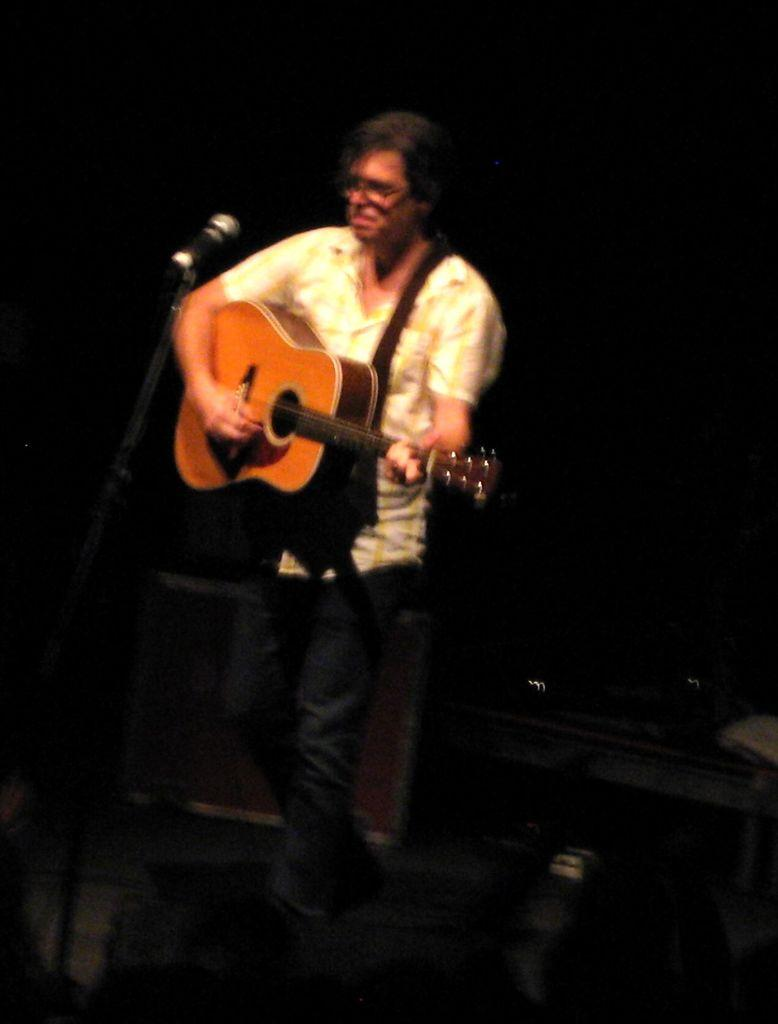Who is the main subject in the image? There is a man in the image. What is the man holding in the image? The man is holding a guitar. What object is in front of the man? There is a microphone in front of the man. What type of throne is the man sitting on in the image? There is no throne present in the image; the man is standing while holding a guitar. How does the man's sneeze affect the sound of the guitar in the image? The man is not sneezing in the image, and there is no indication that his sneeze would affect the sound of the guitar. 